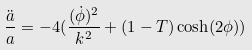Convert formula to latex. <formula><loc_0><loc_0><loc_500><loc_500>\frac { \ddot { a } } { a } = - 4 ( \frac { ( \dot { \phi } ) ^ { 2 } } { k ^ { 2 } } + ( 1 - T ) \cosh ( 2 \phi ) )</formula> 